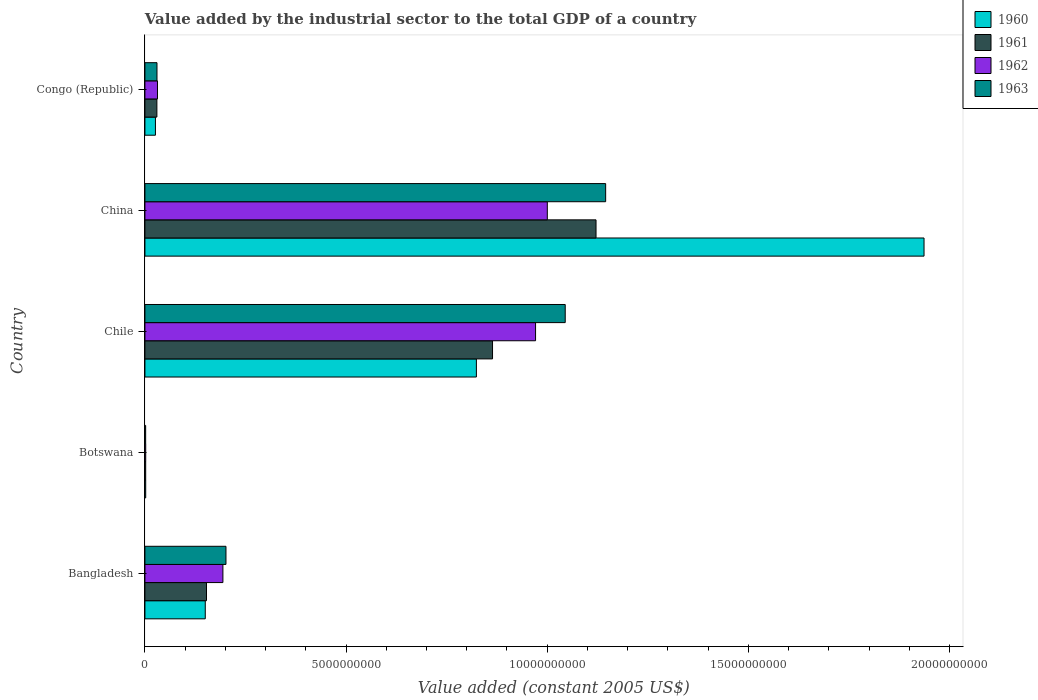How many different coloured bars are there?
Keep it short and to the point. 4. How many bars are there on the 1st tick from the bottom?
Provide a short and direct response. 4. What is the label of the 2nd group of bars from the top?
Your answer should be very brief. China. In how many cases, is the number of bars for a given country not equal to the number of legend labels?
Provide a short and direct response. 0. What is the value added by the industrial sector in 1960 in Chile?
Your answer should be compact. 8.24e+09. Across all countries, what is the maximum value added by the industrial sector in 1960?
Offer a very short reply. 1.94e+1. Across all countries, what is the minimum value added by the industrial sector in 1960?
Give a very brief answer. 1.96e+07. In which country was the value added by the industrial sector in 1960 minimum?
Provide a short and direct response. Botswana. What is the total value added by the industrial sector in 1962 in the graph?
Your response must be concise. 2.20e+1. What is the difference between the value added by the industrial sector in 1962 in Bangladesh and that in Chile?
Offer a terse response. -7.77e+09. What is the difference between the value added by the industrial sector in 1961 in Botswana and the value added by the industrial sector in 1960 in Congo (Republic)?
Your response must be concise. -2.42e+08. What is the average value added by the industrial sector in 1961 per country?
Provide a short and direct response. 4.34e+09. What is the difference between the value added by the industrial sector in 1960 and value added by the industrial sector in 1963 in Congo (Republic)?
Make the answer very short. -3.84e+07. What is the ratio of the value added by the industrial sector in 1963 in Bangladesh to that in Botswana?
Your response must be concise. 109.83. What is the difference between the highest and the second highest value added by the industrial sector in 1960?
Your answer should be compact. 1.11e+1. What is the difference between the highest and the lowest value added by the industrial sector in 1963?
Give a very brief answer. 1.14e+1. In how many countries, is the value added by the industrial sector in 1961 greater than the average value added by the industrial sector in 1961 taken over all countries?
Your answer should be very brief. 2. Is it the case that in every country, the sum of the value added by the industrial sector in 1962 and value added by the industrial sector in 1961 is greater than the sum of value added by the industrial sector in 1963 and value added by the industrial sector in 1960?
Keep it short and to the point. No. What does the 2nd bar from the top in Chile represents?
Your answer should be very brief. 1962. What does the 2nd bar from the bottom in China represents?
Make the answer very short. 1961. Are all the bars in the graph horizontal?
Provide a short and direct response. Yes. What is the difference between two consecutive major ticks on the X-axis?
Keep it short and to the point. 5.00e+09. Does the graph contain grids?
Keep it short and to the point. No. Where does the legend appear in the graph?
Your response must be concise. Top right. What is the title of the graph?
Keep it short and to the point. Value added by the industrial sector to the total GDP of a country. What is the label or title of the X-axis?
Provide a short and direct response. Value added (constant 2005 US$). What is the Value added (constant 2005 US$) of 1960 in Bangladesh?
Your answer should be compact. 1.50e+09. What is the Value added (constant 2005 US$) in 1961 in Bangladesh?
Give a very brief answer. 1.53e+09. What is the Value added (constant 2005 US$) in 1962 in Bangladesh?
Your response must be concise. 1.94e+09. What is the Value added (constant 2005 US$) of 1963 in Bangladesh?
Make the answer very short. 2.01e+09. What is the Value added (constant 2005 US$) of 1960 in Botswana?
Provide a succinct answer. 1.96e+07. What is the Value added (constant 2005 US$) of 1961 in Botswana?
Offer a very short reply. 1.92e+07. What is the Value added (constant 2005 US$) of 1962 in Botswana?
Your answer should be very brief. 1.98e+07. What is the Value added (constant 2005 US$) in 1963 in Botswana?
Offer a very short reply. 1.83e+07. What is the Value added (constant 2005 US$) of 1960 in Chile?
Offer a very short reply. 8.24e+09. What is the Value added (constant 2005 US$) in 1961 in Chile?
Your response must be concise. 8.64e+09. What is the Value added (constant 2005 US$) of 1962 in Chile?
Give a very brief answer. 9.71e+09. What is the Value added (constant 2005 US$) of 1963 in Chile?
Provide a succinct answer. 1.04e+1. What is the Value added (constant 2005 US$) of 1960 in China?
Your response must be concise. 1.94e+1. What is the Value added (constant 2005 US$) in 1961 in China?
Your answer should be very brief. 1.12e+1. What is the Value added (constant 2005 US$) of 1962 in China?
Your response must be concise. 1.00e+1. What is the Value added (constant 2005 US$) of 1963 in China?
Your answer should be very brief. 1.15e+1. What is the Value added (constant 2005 US$) of 1960 in Congo (Republic)?
Ensure brevity in your answer.  2.61e+08. What is the Value added (constant 2005 US$) in 1961 in Congo (Republic)?
Make the answer very short. 2.98e+08. What is the Value added (constant 2005 US$) in 1962 in Congo (Republic)?
Make the answer very short. 3.12e+08. What is the Value added (constant 2005 US$) in 1963 in Congo (Republic)?
Your answer should be very brief. 3.00e+08. Across all countries, what is the maximum Value added (constant 2005 US$) of 1960?
Your response must be concise. 1.94e+1. Across all countries, what is the maximum Value added (constant 2005 US$) of 1961?
Keep it short and to the point. 1.12e+1. Across all countries, what is the maximum Value added (constant 2005 US$) in 1962?
Your response must be concise. 1.00e+1. Across all countries, what is the maximum Value added (constant 2005 US$) in 1963?
Give a very brief answer. 1.15e+1. Across all countries, what is the minimum Value added (constant 2005 US$) of 1960?
Your response must be concise. 1.96e+07. Across all countries, what is the minimum Value added (constant 2005 US$) in 1961?
Keep it short and to the point. 1.92e+07. Across all countries, what is the minimum Value added (constant 2005 US$) of 1962?
Your response must be concise. 1.98e+07. Across all countries, what is the minimum Value added (constant 2005 US$) of 1963?
Give a very brief answer. 1.83e+07. What is the total Value added (constant 2005 US$) in 1960 in the graph?
Keep it short and to the point. 2.94e+1. What is the total Value added (constant 2005 US$) of 1961 in the graph?
Offer a terse response. 2.17e+1. What is the total Value added (constant 2005 US$) of 1962 in the graph?
Provide a succinct answer. 2.20e+1. What is the total Value added (constant 2005 US$) of 1963 in the graph?
Offer a terse response. 2.42e+1. What is the difference between the Value added (constant 2005 US$) in 1960 in Bangladesh and that in Botswana?
Your answer should be very brief. 1.48e+09. What is the difference between the Value added (constant 2005 US$) in 1961 in Bangladesh and that in Botswana?
Provide a succinct answer. 1.51e+09. What is the difference between the Value added (constant 2005 US$) of 1962 in Bangladesh and that in Botswana?
Provide a short and direct response. 1.92e+09. What is the difference between the Value added (constant 2005 US$) of 1963 in Bangladesh and that in Botswana?
Provide a short and direct response. 2.00e+09. What is the difference between the Value added (constant 2005 US$) of 1960 in Bangladesh and that in Chile?
Offer a terse response. -6.74e+09. What is the difference between the Value added (constant 2005 US$) in 1961 in Bangladesh and that in Chile?
Ensure brevity in your answer.  -7.11e+09. What is the difference between the Value added (constant 2005 US$) in 1962 in Bangladesh and that in Chile?
Your answer should be compact. -7.77e+09. What is the difference between the Value added (constant 2005 US$) in 1963 in Bangladesh and that in Chile?
Your answer should be compact. -8.43e+09. What is the difference between the Value added (constant 2005 US$) in 1960 in Bangladesh and that in China?
Provide a succinct answer. -1.79e+1. What is the difference between the Value added (constant 2005 US$) in 1961 in Bangladesh and that in China?
Keep it short and to the point. -9.68e+09. What is the difference between the Value added (constant 2005 US$) in 1962 in Bangladesh and that in China?
Provide a short and direct response. -8.06e+09. What is the difference between the Value added (constant 2005 US$) of 1963 in Bangladesh and that in China?
Your answer should be very brief. -9.44e+09. What is the difference between the Value added (constant 2005 US$) in 1960 in Bangladesh and that in Congo (Republic)?
Provide a short and direct response. 1.24e+09. What is the difference between the Value added (constant 2005 US$) of 1961 in Bangladesh and that in Congo (Republic)?
Provide a short and direct response. 1.23e+09. What is the difference between the Value added (constant 2005 US$) in 1962 in Bangladesh and that in Congo (Republic)?
Ensure brevity in your answer.  1.63e+09. What is the difference between the Value added (constant 2005 US$) in 1963 in Bangladesh and that in Congo (Republic)?
Provide a short and direct response. 1.71e+09. What is the difference between the Value added (constant 2005 US$) of 1960 in Botswana and that in Chile?
Make the answer very short. -8.22e+09. What is the difference between the Value added (constant 2005 US$) in 1961 in Botswana and that in Chile?
Offer a very short reply. -8.62e+09. What is the difference between the Value added (constant 2005 US$) in 1962 in Botswana and that in Chile?
Offer a terse response. -9.69e+09. What is the difference between the Value added (constant 2005 US$) in 1963 in Botswana and that in Chile?
Your answer should be compact. -1.04e+1. What is the difference between the Value added (constant 2005 US$) in 1960 in Botswana and that in China?
Your answer should be compact. -1.93e+1. What is the difference between the Value added (constant 2005 US$) in 1961 in Botswana and that in China?
Offer a very short reply. -1.12e+1. What is the difference between the Value added (constant 2005 US$) of 1962 in Botswana and that in China?
Your response must be concise. -9.98e+09. What is the difference between the Value added (constant 2005 US$) of 1963 in Botswana and that in China?
Give a very brief answer. -1.14e+1. What is the difference between the Value added (constant 2005 US$) in 1960 in Botswana and that in Congo (Republic)?
Ensure brevity in your answer.  -2.42e+08. What is the difference between the Value added (constant 2005 US$) in 1961 in Botswana and that in Congo (Republic)?
Provide a short and direct response. -2.78e+08. What is the difference between the Value added (constant 2005 US$) of 1962 in Botswana and that in Congo (Republic)?
Offer a terse response. -2.93e+08. What is the difference between the Value added (constant 2005 US$) in 1963 in Botswana and that in Congo (Republic)?
Keep it short and to the point. -2.81e+08. What is the difference between the Value added (constant 2005 US$) in 1960 in Chile and that in China?
Your answer should be compact. -1.11e+1. What is the difference between the Value added (constant 2005 US$) in 1961 in Chile and that in China?
Ensure brevity in your answer.  -2.57e+09. What is the difference between the Value added (constant 2005 US$) of 1962 in Chile and that in China?
Offer a very short reply. -2.92e+08. What is the difference between the Value added (constant 2005 US$) of 1963 in Chile and that in China?
Your answer should be very brief. -1.01e+09. What is the difference between the Value added (constant 2005 US$) in 1960 in Chile and that in Congo (Republic)?
Your answer should be very brief. 7.98e+09. What is the difference between the Value added (constant 2005 US$) of 1961 in Chile and that in Congo (Republic)?
Offer a terse response. 8.34e+09. What is the difference between the Value added (constant 2005 US$) in 1962 in Chile and that in Congo (Republic)?
Keep it short and to the point. 9.40e+09. What is the difference between the Value added (constant 2005 US$) in 1963 in Chile and that in Congo (Republic)?
Your answer should be compact. 1.01e+1. What is the difference between the Value added (constant 2005 US$) in 1960 in China and that in Congo (Republic)?
Ensure brevity in your answer.  1.91e+1. What is the difference between the Value added (constant 2005 US$) in 1961 in China and that in Congo (Republic)?
Offer a terse response. 1.09e+1. What is the difference between the Value added (constant 2005 US$) of 1962 in China and that in Congo (Republic)?
Your answer should be compact. 9.69e+09. What is the difference between the Value added (constant 2005 US$) of 1963 in China and that in Congo (Republic)?
Provide a succinct answer. 1.12e+1. What is the difference between the Value added (constant 2005 US$) of 1960 in Bangladesh and the Value added (constant 2005 US$) of 1961 in Botswana?
Your answer should be compact. 1.48e+09. What is the difference between the Value added (constant 2005 US$) of 1960 in Bangladesh and the Value added (constant 2005 US$) of 1962 in Botswana?
Keep it short and to the point. 1.48e+09. What is the difference between the Value added (constant 2005 US$) of 1960 in Bangladesh and the Value added (constant 2005 US$) of 1963 in Botswana?
Make the answer very short. 1.48e+09. What is the difference between the Value added (constant 2005 US$) in 1961 in Bangladesh and the Value added (constant 2005 US$) in 1962 in Botswana?
Your answer should be compact. 1.51e+09. What is the difference between the Value added (constant 2005 US$) in 1961 in Bangladesh and the Value added (constant 2005 US$) in 1963 in Botswana?
Your answer should be compact. 1.51e+09. What is the difference between the Value added (constant 2005 US$) in 1962 in Bangladesh and the Value added (constant 2005 US$) in 1963 in Botswana?
Offer a terse response. 1.92e+09. What is the difference between the Value added (constant 2005 US$) in 1960 in Bangladesh and the Value added (constant 2005 US$) in 1961 in Chile?
Ensure brevity in your answer.  -7.14e+09. What is the difference between the Value added (constant 2005 US$) in 1960 in Bangladesh and the Value added (constant 2005 US$) in 1962 in Chile?
Your response must be concise. -8.21e+09. What is the difference between the Value added (constant 2005 US$) in 1960 in Bangladesh and the Value added (constant 2005 US$) in 1963 in Chile?
Offer a very short reply. -8.95e+09. What is the difference between the Value added (constant 2005 US$) of 1961 in Bangladesh and the Value added (constant 2005 US$) of 1962 in Chile?
Keep it short and to the point. -8.18e+09. What is the difference between the Value added (constant 2005 US$) in 1961 in Bangladesh and the Value added (constant 2005 US$) in 1963 in Chile?
Provide a succinct answer. -8.92e+09. What is the difference between the Value added (constant 2005 US$) of 1962 in Bangladesh and the Value added (constant 2005 US$) of 1963 in Chile?
Offer a terse response. -8.51e+09. What is the difference between the Value added (constant 2005 US$) of 1960 in Bangladesh and the Value added (constant 2005 US$) of 1961 in China?
Give a very brief answer. -9.71e+09. What is the difference between the Value added (constant 2005 US$) of 1960 in Bangladesh and the Value added (constant 2005 US$) of 1962 in China?
Your answer should be compact. -8.50e+09. What is the difference between the Value added (constant 2005 US$) of 1960 in Bangladesh and the Value added (constant 2005 US$) of 1963 in China?
Offer a terse response. -9.95e+09. What is the difference between the Value added (constant 2005 US$) in 1961 in Bangladesh and the Value added (constant 2005 US$) in 1962 in China?
Provide a short and direct response. -8.47e+09. What is the difference between the Value added (constant 2005 US$) in 1961 in Bangladesh and the Value added (constant 2005 US$) in 1963 in China?
Make the answer very short. -9.92e+09. What is the difference between the Value added (constant 2005 US$) in 1962 in Bangladesh and the Value added (constant 2005 US$) in 1963 in China?
Make the answer very short. -9.51e+09. What is the difference between the Value added (constant 2005 US$) of 1960 in Bangladesh and the Value added (constant 2005 US$) of 1961 in Congo (Republic)?
Make the answer very short. 1.20e+09. What is the difference between the Value added (constant 2005 US$) in 1960 in Bangladesh and the Value added (constant 2005 US$) in 1962 in Congo (Republic)?
Your answer should be compact. 1.19e+09. What is the difference between the Value added (constant 2005 US$) in 1960 in Bangladesh and the Value added (constant 2005 US$) in 1963 in Congo (Republic)?
Provide a short and direct response. 1.20e+09. What is the difference between the Value added (constant 2005 US$) in 1961 in Bangladesh and the Value added (constant 2005 US$) in 1962 in Congo (Republic)?
Provide a short and direct response. 1.22e+09. What is the difference between the Value added (constant 2005 US$) in 1961 in Bangladesh and the Value added (constant 2005 US$) in 1963 in Congo (Republic)?
Offer a terse response. 1.23e+09. What is the difference between the Value added (constant 2005 US$) in 1962 in Bangladesh and the Value added (constant 2005 US$) in 1963 in Congo (Republic)?
Provide a succinct answer. 1.64e+09. What is the difference between the Value added (constant 2005 US$) of 1960 in Botswana and the Value added (constant 2005 US$) of 1961 in Chile?
Provide a short and direct response. -8.62e+09. What is the difference between the Value added (constant 2005 US$) in 1960 in Botswana and the Value added (constant 2005 US$) in 1962 in Chile?
Provide a succinct answer. -9.69e+09. What is the difference between the Value added (constant 2005 US$) in 1960 in Botswana and the Value added (constant 2005 US$) in 1963 in Chile?
Your answer should be very brief. -1.04e+1. What is the difference between the Value added (constant 2005 US$) in 1961 in Botswana and the Value added (constant 2005 US$) in 1962 in Chile?
Keep it short and to the point. -9.69e+09. What is the difference between the Value added (constant 2005 US$) of 1961 in Botswana and the Value added (constant 2005 US$) of 1963 in Chile?
Offer a terse response. -1.04e+1. What is the difference between the Value added (constant 2005 US$) of 1962 in Botswana and the Value added (constant 2005 US$) of 1963 in Chile?
Your answer should be very brief. -1.04e+1. What is the difference between the Value added (constant 2005 US$) of 1960 in Botswana and the Value added (constant 2005 US$) of 1961 in China?
Offer a terse response. -1.12e+1. What is the difference between the Value added (constant 2005 US$) in 1960 in Botswana and the Value added (constant 2005 US$) in 1962 in China?
Your response must be concise. -9.98e+09. What is the difference between the Value added (constant 2005 US$) of 1960 in Botswana and the Value added (constant 2005 US$) of 1963 in China?
Offer a terse response. -1.14e+1. What is the difference between the Value added (constant 2005 US$) of 1961 in Botswana and the Value added (constant 2005 US$) of 1962 in China?
Provide a short and direct response. -9.98e+09. What is the difference between the Value added (constant 2005 US$) in 1961 in Botswana and the Value added (constant 2005 US$) in 1963 in China?
Your response must be concise. -1.14e+1. What is the difference between the Value added (constant 2005 US$) of 1962 in Botswana and the Value added (constant 2005 US$) of 1963 in China?
Offer a terse response. -1.14e+1. What is the difference between the Value added (constant 2005 US$) in 1960 in Botswana and the Value added (constant 2005 US$) in 1961 in Congo (Republic)?
Offer a terse response. -2.78e+08. What is the difference between the Value added (constant 2005 US$) in 1960 in Botswana and the Value added (constant 2005 US$) in 1962 in Congo (Republic)?
Give a very brief answer. -2.93e+08. What is the difference between the Value added (constant 2005 US$) in 1960 in Botswana and the Value added (constant 2005 US$) in 1963 in Congo (Republic)?
Your answer should be very brief. -2.80e+08. What is the difference between the Value added (constant 2005 US$) of 1961 in Botswana and the Value added (constant 2005 US$) of 1962 in Congo (Republic)?
Offer a very short reply. -2.93e+08. What is the difference between the Value added (constant 2005 US$) of 1961 in Botswana and the Value added (constant 2005 US$) of 1963 in Congo (Republic)?
Your answer should be very brief. -2.81e+08. What is the difference between the Value added (constant 2005 US$) in 1962 in Botswana and the Value added (constant 2005 US$) in 1963 in Congo (Republic)?
Make the answer very short. -2.80e+08. What is the difference between the Value added (constant 2005 US$) of 1960 in Chile and the Value added (constant 2005 US$) of 1961 in China?
Keep it short and to the point. -2.97e+09. What is the difference between the Value added (constant 2005 US$) in 1960 in Chile and the Value added (constant 2005 US$) in 1962 in China?
Keep it short and to the point. -1.76e+09. What is the difference between the Value added (constant 2005 US$) in 1960 in Chile and the Value added (constant 2005 US$) in 1963 in China?
Keep it short and to the point. -3.21e+09. What is the difference between the Value added (constant 2005 US$) of 1961 in Chile and the Value added (constant 2005 US$) of 1962 in China?
Offer a very short reply. -1.36e+09. What is the difference between the Value added (constant 2005 US$) in 1961 in Chile and the Value added (constant 2005 US$) in 1963 in China?
Offer a very short reply. -2.81e+09. What is the difference between the Value added (constant 2005 US$) in 1962 in Chile and the Value added (constant 2005 US$) in 1963 in China?
Your response must be concise. -1.74e+09. What is the difference between the Value added (constant 2005 US$) of 1960 in Chile and the Value added (constant 2005 US$) of 1961 in Congo (Republic)?
Provide a short and direct response. 7.94e+09. What is the difference between the Value added (constant 2005 US$) in 1960 in Chile and the Value added (constant 2005 US$) in 1962 in Congo (Republic)?
Offer a very short reply. 7.93e+09. What is the difference between the Value added (constant 2005 US$) of 1960 in Chile and the Value added (constant 2005 US$) of 1963 in Congo (Republic)?
Offer a very short reply. 7.94e+09. What is the difference between the Value added (constant 2005 US$) of 1961 in Chile and the Value added (constant 2005 US$) of 1962 in Congo (Republic)?
Your answer should be very brief. 8.33e+09. What is the difference between the Value added (constant 2005 US$) of 1961 in Chile and the Value added (constant 2005 US$) of 1963 in Congo (Republic)?
Give a very brief answer. 8.34e+09. What is the difference between the Value added (constant 2005 US$) of 1962 in Chile and the Value added (constant 2005 US$) of 1963 in Congo (Republic)?
Your answer should be very brief. 9.41e+09. What is the difference between the Value added (constant 2005 US$) in 1960 in China and the Value added (constant 2005 US$) in 1961 in Congo (Republic)?
Your answer should be very brief. 1.91e+1. What is the difference between the Value added (constant 2005 US$) of 1960 in China and the Value added (constant 2005 US$) of 1962 in Congo (Republic)?
Offer a terse response. 1.91e+1. What is the difference between the Value added (constant 2005 US$) of 1960 in China and the Value added (constant 2005 US$) of 1963 in Congo (Republic)?
Make the answer very short. 1.91e+1. What is the difference between the Value added (constant 2005 US$) in 1961 in China and the Value added (constant 2005 US$) in 1962 in Congo (Republic)?
Ensure brevity in your answer.  1.09e+1. What is the difference between the Value added (constant 2005 US$) of 1961 in China and the Value added (constant 2005 US$) of 1963 in Congo (Republic)?
Keep it short and to the point. 1.09e+1. What is the difference between the Value added (constant 2005 US$) of 1962 in China and the Value added (constant 2005 US$) of 1963 in Congo (Republic)?
Offer a very short reply. 9.70e+09. What is the average Value added (constant 2005 US$) in 1960 per country?
Provide a succinct answer. 5.88e+09. What is the average Value added (constant 2005 US$) of 1961 per country?
Offer a very short reply. 4.34e+09. What is the average Value added (constant 2005 US$) in 1962 per country?
Your answer should be compact. 4.40e+09. What is the average Value added (constant 2005 US$) of 1963 per country?
Make the answer very short. 4.85e+09. What is the difference between the Value added (constant 2005 US$) in 1960 and Value added (constant 2005 US$) in 1961 in Bangladesh?
Give a very brief answer. -3.05e+07. What is the difference between the Value added (constant 2005 US$) in 1960 and Value added (constant 2005 US$) in 1962 in Bangladesh?
Your answer should be very brief. -4.38e+08. What is the difference between the Value added (constant 2005 US$) in 1960 and Value added (constant 2005 US$) in 1963 in Bangladesh?
Your response must be concise. -5.14e+08. What is the difference between the Value added (constant 2005 US$) of 1961 and Value added (constant 2005 US$) of 1962 in Bangladesh?
Offer a very short reply. -4.08e+08. What is the difference between the Value added (constant 2005 US$) of 1961 and Value added (constant 2005 US$) of 1963 in Bangladesh?
Your answer should be compact. -4.84e+08. What is the difference between the Value added (constant 2005 US$) of 1962 and Value added (constant 2005 US$) of 1963 in Bangladesh?
Your response must be concise. -7.60e+07. What is the difference between the Value added (constant 2005 US$) of 1960 and Value added (constant 2005 US$) of 1961 in Botswana?
Give a very brief answer. 4.24e+05. What is the difference between the Value added (constant 2005 US$) in 1960 and Value added (constant 2005 US$) in 1962 in Botswana?
Make the answer very short. -2.12e+05. What is the difference between the Value added (constant 2005 US$) in 1960 and Value added (constant 2005 US$) in 1963 in Botswana?
Keep it short and to the point. 1.27e+06. What is the difference between the Value added (constant 2005 US$) of 1961 and Value added (constant 2005 US$) of 1962 in Botswana?
Offer a very short reply. -6.36e+05. What is the difference between the Value added (constant 2005 US$) of 1961 and Value added (constant 2005 US$) of 1963 in Botswana?
Keep it short and to the point. 8.48e+05. What is the difference between the Value added (constant 2005 US$) in 1962 and Value added (constant 2005 US$) in 1963 in Botswana?
Keep it short and to the point. 1.48e+06. What is the difference between the Value added (constant 2005 US$) of 1960 and Value added (constant 2005 US$) of 1961 in Chile?
Keep it short and to the point. -4.01e+08. What is the difference between the Value added (constant 2005 US$) of 1960 and Value added (constant 2005 US$) of 1962 in Chile?
Offer a very short reply. -1.47e+09. What is the difference between the Value added (constant 2005 US$) in 1960 and Value added (constant 2005 US$) in 1963 in Chile?
Offer a terse response. -2.21e+09. What is the difference between the Value added (constant 2005 US$) of 1961 and Value added (constant 2005 US$) of 1962 in Chile?
Your answer should be very brief. -1.07e+09. What is the difference between the Value added (constant 2005 US$) in 1961 and Value added (constant 2005 US$) in 1963 in Chile?
Keep it short and to the point. -1.81e+09. What is the difference between the Value added (constant 2005 US$) in 1962 and Value added (constant 2005 US$) in 1963 in Chile?
Your answer should be very brief. -7.37e+08. What is the difference between the Value added (constant 2005 US$) in 1960 and Value added (constant 2005 US$) in 1961 in China?
Keep it short and to the point. 8.15e+09. What is the difference between the Value added (constant 2005 US$) in 1960 and Value added (constant 2005 US$) in 1962 in China?
Give a very brief answer. 9.36e+09. What is the difference between the Value added (constant 2005 US$) of 1960 and Value added (constant 2005 US$) of 1963 in China?
Provide a short and direct response. 7.91e+09. What is the difference between the Value added (constant 2005 US$) in 1961 and Value added (constant 2005 US$) in 1962 in China?
Make the answer very short. 1.21e+09. What is the difference between the Value added (constant 2005 US$) in 1961 and Value added (constant 2005 US$) in 1963 in China?
Make the answer very short. -2.39e+08. What is the difference between the Value added (constant 2005 US$) of 1962 and Value added (constant 2005 US$) of 1963 in China?
Provide a short and direct response. -1.45e+09. What is the difference between the Value added (constant 2005 US$) of 1960 and Value added (constant 2005 US$) of 1961 in Congo (Republic)?
Make the answer very short. -3.63e+07. What is the difference between the Value added (constant 2005 US$) of 1960 and Value added (constant 2005 US$) of 1962 in Congo (Republic)?
Your response must be concise. -5.10e+07. What is the difference between the Value added (constant 2005 US$) in 1960 and Value added (constant 2005 US$) in 1963 in Congo (Republic)?
Your answer should be compact. -3.84e+07. What is the difference between the Value added (constant 2005 US$) in 1961 and Value added (constant 2005 US$) in 1962 in Congo (Republic)?
Give a very brief answer. -1.47e+07. What is the difference between the Value added (constant 2005 US$) of 1961 and Value added (constant 2005 US$) of 1963 in Congo (Republic)?
Give a very brief answer. -2.10e+06. What is the difference between the Value added (constant 2005 US$) of 1962 and Value added (constant 2005 US$) of 1963 in Congo (Republic)?
Offer a terse response. 1.26e+07. What is the ratio of the Value added (constant 2005 US$) of 1960 in Bangladesh to that in Botswana?
Give a very brief answer. 76.48. What is the ratio of the Value added (constant 2005 US$) in 1961 in Bangladesh to that in Botswana?
Provide a short and direct response. 79.76. What is the ratio of the Value added (constant 2005 US$) in 1962 in Bangladesh to that in Botswana?
Keep it short and to the point. 97.78. What is the ratio of the Value added (constant 2005 US$) in 1963 in Bangladesh to that in Botswana?
Provide a short and direct response. 109.83. What is the ratio of the Value added (constant 2005 US$) of 1960 in Bangladesh to that in Chile?
Ensure brevity in your answer.  0.18. What is the ratio of the Value added (constant 2005 US$) in 1961 in Bangladesh to that in Chile?
Provide a short and direct response. 0.18. What is the ratio of the Value added (constant 2005 US$) in 1962 in Bangladesh to that in Chile?
Offer a terse response. 0.2. What is the ratio of the Value added (constant 2005 US$) of 1963 in Bangladesh to that in Chile?
Offer a very short reply. 0.19. What is the ratio of the Value added (constant 2005 US$) in 1960 in Bangladesh to that in China?
Provide a short and direct response. 0.08. What is the ratio of the Value added (constant 2005 US$) of 1961 in Bangladesh to that in China?
Keep it short and to the point. 0.14. What is the ratio of the Value added (constant 2005 US$) in 1962 in Bangladesh to that in China?
Provide a short and direct response. 0.19. What is the ratio of the Value added (constant 2005 US$) of 1963 in Bangladesh to that in China?
Your answer should be very brief. 0.18. What is the ratio of the Value added (constant 2005 US$) in 1960 in Bangladesh to that in Congo (Republic)?
Provide a succinct answer. 5.74. What is the ratio of the Value added (constant 2005 US$) in 1961 in Bangladesh to that in Congo (Republic)?
Keep it short and to the point. 5.14. What is the ratio of the Value added (constant 2005 US$) of 1962 in Bangladesh to that in Congo (Republic)?
Offer a very short reply. 6.21. What is the ratio of the Value added (constant 2005 US$) of 1963 in Bangladesh to that in Congo (Republic)?
Your answer should be compact. 6.72. What is the ratio of the Value added (constant 2005 US$) of 1960 in Botswana to that in Chile?
Ensure brevity in your answer.  0. What is the ratio of the Value added (constant 2005 US$) in 1961 in Botswana to that in Chile?
Make the answer very short. 0. What is the ratio of the Value added (constant 2005 US$) in 1962 in Botswana to that in Chile?
Ensure brevity in your answer.  0. What is the ratio of the Value added (constant 2005 US$) of 1963 in Botswana to that in Chile?
Offer a terse response. 0. What is the ratio of the Value added (constant 2005 US$) in 1961 in Botswana to that in China?
Your answer should be very brief. 0. What is the ratio of the Value added (constant 2005 US$) of 1962 in Botswana to that in China?
Provide a short and direct response. 0. What is the ratio of the Value added (constant 2005 US$) in 1963 in Botswana to that in China?
Your answer should be compact. 0. What is the ratio of the Value added (constant 2005 US$) of 1960 in Botswana to that in Congo (Republic)?
Your response must be concise. 0.07. What is the ratio of the Value added (constant 2005 US$) in 1961 in Botswana to that in Congo (Republic)?
Your answer should be compact. 0.06. What is the ratio of the Value added (constant 2005 US$) in 1962 in Botswana to that in Congo (Republic)?
Provide a succinct answer. 0.06. What is the ratio of the Value added (constant 2005 US$) in 1963 in Botswana to that in Congo (Republic)?
Offer a very short reply. 0.06. What is the ratio of the Value added (constant 2005 US$) in 1960 in Chile to that in China?
Offer a very short reply. 0.43. What is the ratio of the Value added (constant 2005 US$) of 1961 in Chile to that in China?
Make the answer very short. 0.77. What is the ratio of the Value added (constant 2005 US$) in 1962 in Chile to that in China?
Make the answer very short. 0.97. What is the ratio of the Value added (constant 2005 US$) of 1963 in Chile to that in China?
Keep it short and to the point. 0.91. What is the ratio of the Value added (constant 2005 US$) in 1960 in Chile to that in Congo (Republic)?
Give a very brief answer. 31.52. What is the ratio of the Value added (constant 2005 US$) of 1961 in Chile to that in Congo (Republic)?
Provide a short and direct response. 29.03. What is the ratio of the Value added (constant 2005 US$) of 1962 in Chile to that in Congo (Republic)?
Your answer should be very brief. 31.09. What is the ratio of the Value added (constant 2005 US$) in 1963 in Chile to that in Congo (Republic)?
Give a very brief answer. 34.85. What is the ratio of the Value added (constant 2005 US$) in 1960 in China to that in Congo (Republic)?
Your answer should be compact. 74.09. What is the ratio of the Value added (constant 2005 US$) in 1961 in China to that in Congo (Republic)?
Your response must be concise. 37.67. What is the ratio of the Value added (constant 2005 US$) of 1962 in China to that in Congo (Republic)?
Give a very brief answer. 32.02. What is the ratio of the Value added (constant 2005 US$) in 1963 in China to that in Congo (Republic)?
Give a very brief answer. 38.21. What is the difference between the highest and the second highest Value added (constant 2005 US$) in 1960?
Make the answer very short. 1.11e+1. What is the difference between the highest and the second highest Value added (constant 2005 US$) of 1961?
Your answer should be very brief. 2.57e+09. What is the difference between the highest and the second highest Value added (constant 2005 US$) in 1962?
Provide a succinct answer. 2.92e+08. What is the difference between the highest and the second highest Value added (constant 2005 US$) in 1963?
Make the answer very short. 1.01e+09. What is the difference between the highest and the lowest Value added (constant 2005 US$) in 1960?
Provide a short and direct response. 1.93e+1. What is the difference between the highest and the lowest Value added (constant 2005 US$) in 1961?
Provide a short and direct response. 1.12e+1. What is the difference between the highest and the lowest Value added (constant 2005 US$) in 1962?
Keep it short and to the point. 9.98e+09. What is the difference between the highest and the lowest Value added (constant 2005 US$) in 1963?
Offer a very short reply. 1.14e+1. 